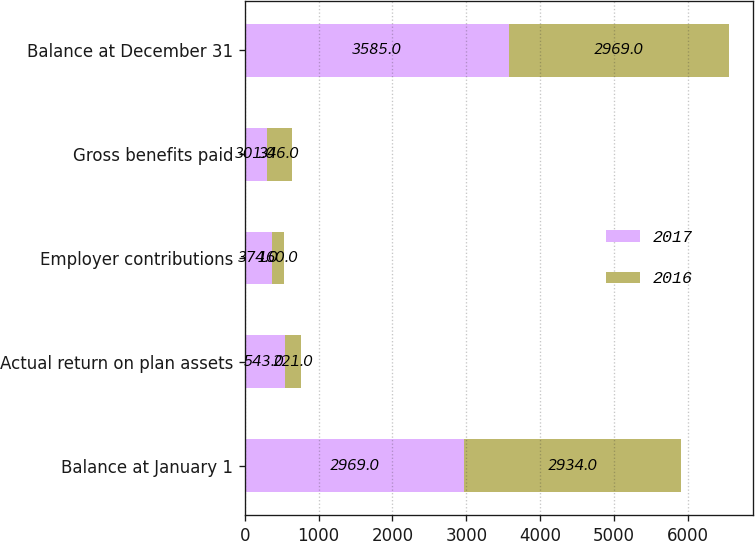<chart> <loc_0><loc_0><loc_500><loc_500><stacked_bar_chart><ecel><fcel>Balance at January 1<fcel>Actual return on plan assets<fcel>Employer contributions<fcel>Gross benefits paid<fcel>Balance at December 31<nl><fcel>2017<fcel>2969<fcel>543<fcel>374<fcel>301<fcel>3585<nl><fcel>2016<fcel>2934<fcel>221<fcel>160<fcel>346<fcel>2969<nl></chart> 